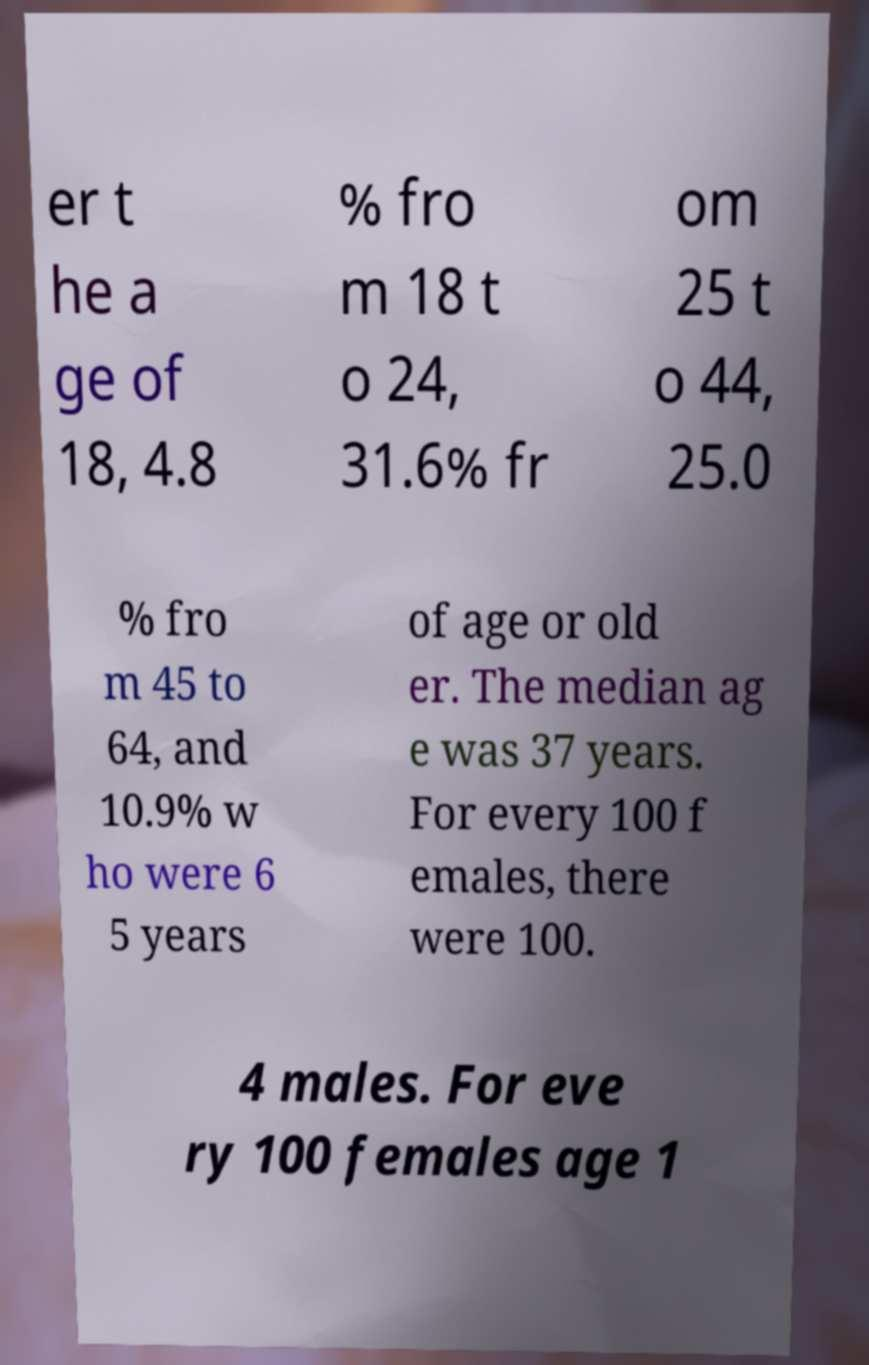I need the written content from this picture converted into text. Can you do that? er t he a ge of 18, 4.8 % fro m 18 t o 24, 31.6% fr om 25 t o 44, 25.0 % fro m 45 to 64, and 10.9% w ho were 6 5 years of age or old er. The median ag e was 37 years. For every 100 f emales, there were 100. 4 males. For eve ry 100 females age 1 